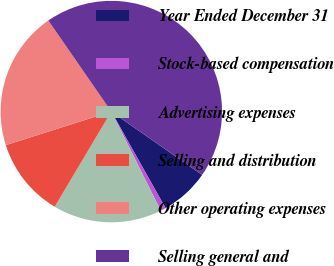<chart> <loc_0><loc_0><loc_500><loc_500><pie_chart><fcel>Year Ended December 31<fcel>Stock-based compensation<fcel>Advertising expenses<fcel>Selling and distribution<fcel>Other operating expenses<fcel>Selling general and<nl><fcel>7.16%<fcel>0.78%<fcel>15.91%<fcel>11.56%<fcel>20.27%<fcel>44.33%<nl></chart> 